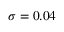Convert formula to latex. <formula><loc_0><loc_0><loc_500><loc_500>\sigma = 0 . 0 4</formula> 